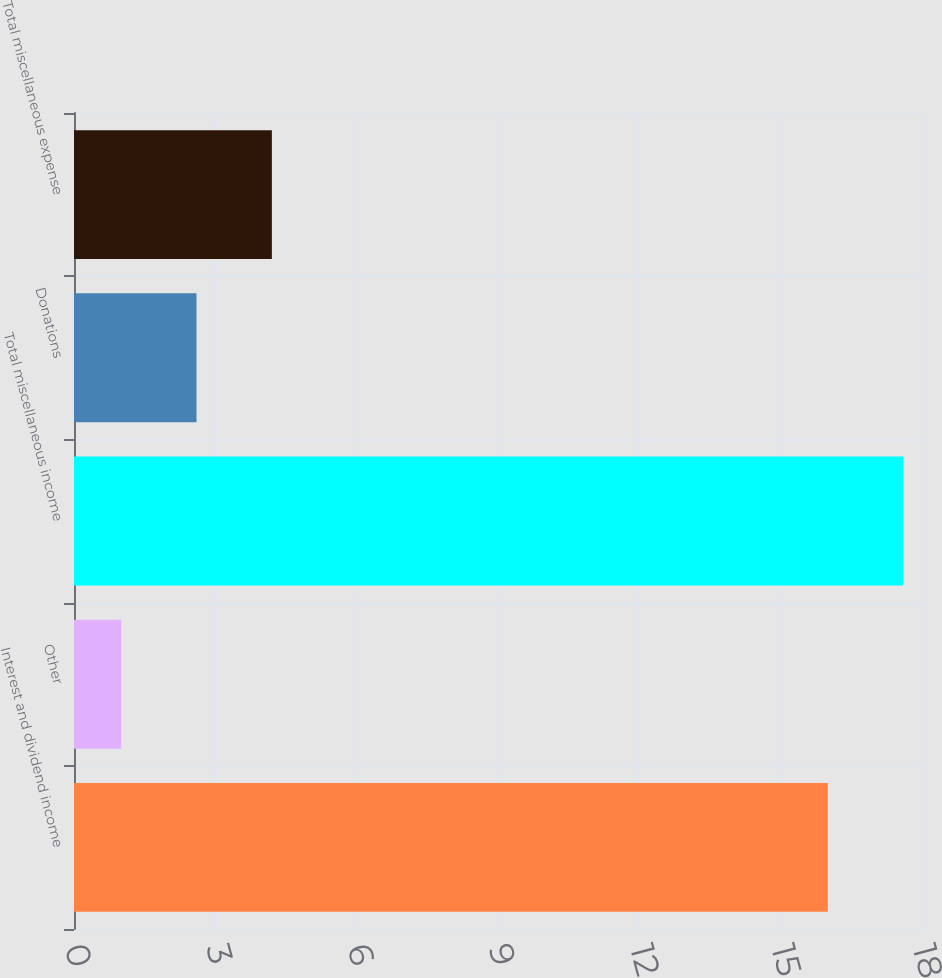Convert chart. <chart><loc_0><loc_0><loc_500><loc_500><bar_chart><fcel>Interest and dividend income<fcel>Other<fcel>Total miscellaneous income<fcel>Donations<fcel>Total miscellaneous expense<nl><fcel>16<fcel>1<fcel>17.6<fcel>2.6<fcel>4.2<nl></chart> 